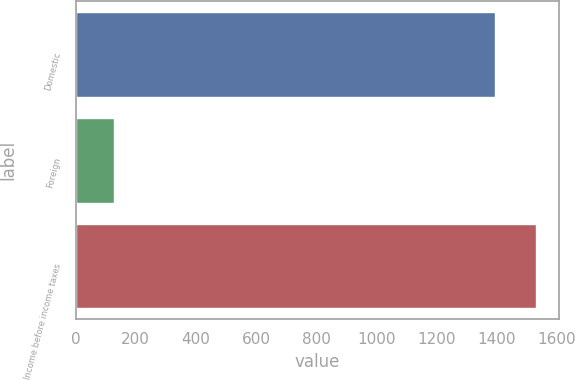Convert chart. <chart><loc_0><loc_0><loc_500><loc_500><bar_chart><fcel>Domestic<fcel>Foreign<fcel>Income before income taxes<nl><fcel>1394<fcel>126<fcel>1533.4<nl></chart> 